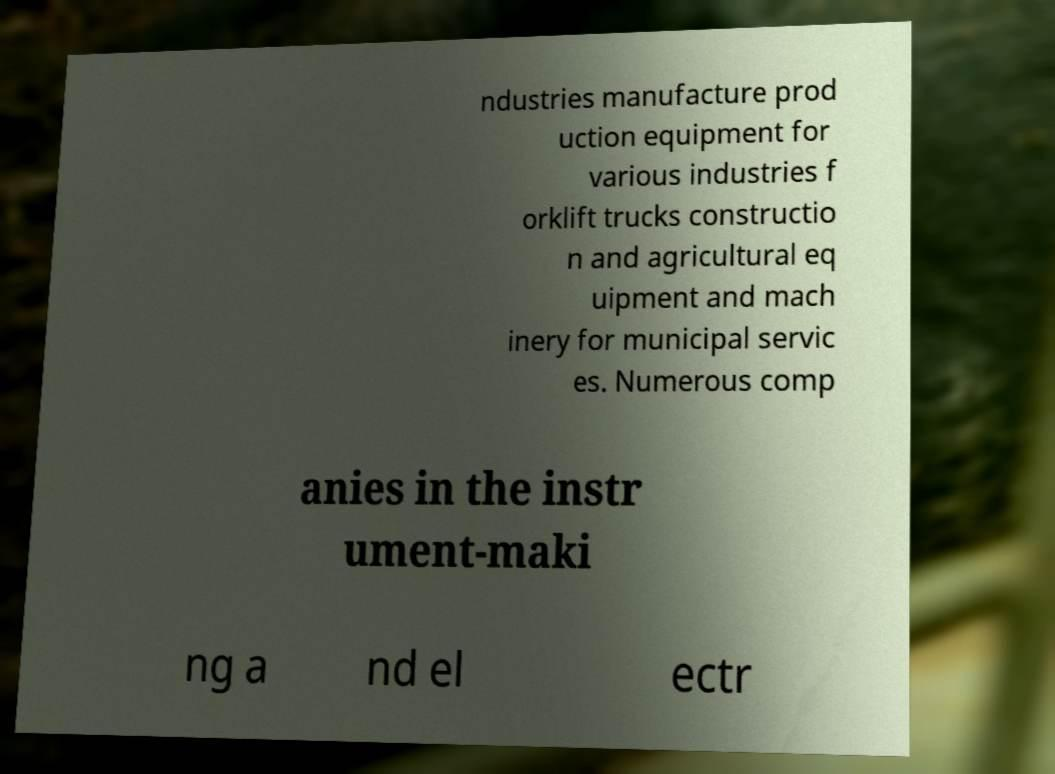What messages or text are displayed in this image? I need them in a readable, typed format. ndustries manufacture prod uction equipment for various industries f orklift trucks constructio n and agricultural eq uipment and mach inery for municipal servic es. Numerous comp anies in the instr ument-maki ng a nd el ectr 